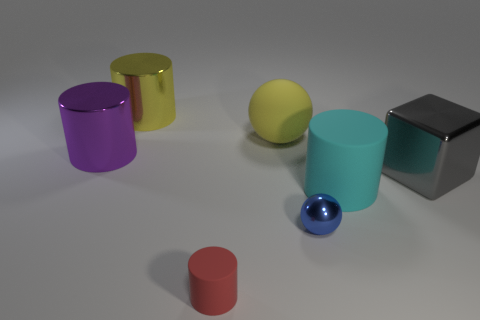The big object that is the same color as the large matte ball is what shape?
Ensure brevity in your answer.  Cylinder. There is a rubber object that is on the right side of the sphere that is in front of the metallic thing on the right side of the small blue ball; what size is it?
Your answer should be compact. Large. What number of other objects are the same shape as the tiny red rubber object?
Ensure brevity in your answer.  3. The shiny object that is behind the tiny blue shiny thing and in front of the purple thing is what color?
Keep it short and to the point. Gray. Is there any other thing that is the same size as the red object?
Your response must be concise. Yes. Do the metal object that is behind the purple metal cylinder and the small shiny ball have the same color?
Ensure brevity in your answer.  No. What number of spheres are either tiny blue objects or yellow matte objects?
Keep it short and to the point. 2. What is the shape of the object that is in front of the blue metallic sphere?
Keep it short and to the point. Cylinder. There is a matte object that is on the left side of the yellow thing on the right side of the large yellow thing that is on the left side of the red cylinder; what is its color?
Ensure brevity in your answer.  Red. Is the tiny red thing made of the same material as the large cyan cylinder?
Your response must be concise. Yes. 